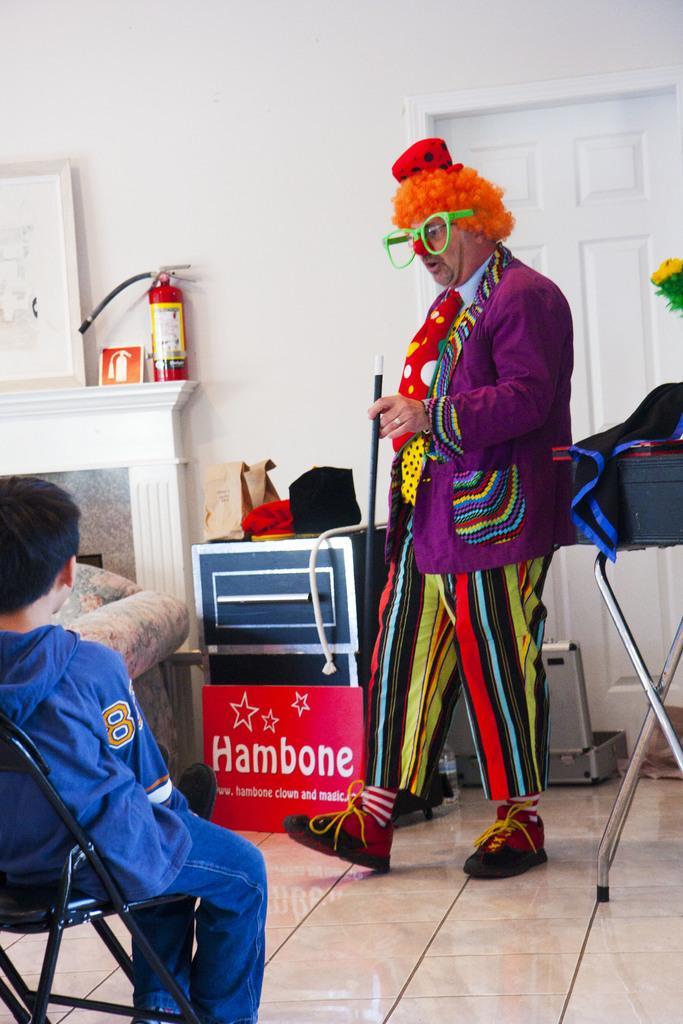How would you summarize this image in a sentence or two? In this image I can see a man is standing and a boy is sitting on a chair. I can see he is wearing costume and here I can see she is wearing blue colour dress. In the background I can see a board, a fire extinguisher, for paper bags, a frame, a white colour door, few boxes and on this board I can see something is written. 